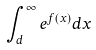<formula> <loc_0><loc_0><loc_500><loc_500>\int _ { d } ^ { \infty } e ^ { f ( x ) } d x</formula> 